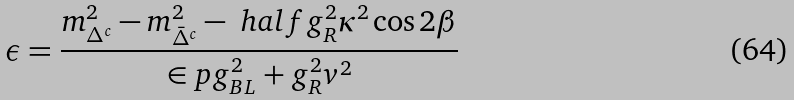Convert formula to latex. <formula><loc_0><loc_0><loc_500><loc_500>\epsilon = \frac { m _ { \Delta ^ { c } } ^ { 2 } - m _ { \bar { \Delta } ^ { c } } ^ { 2 } - \ h a l f g _ { R } ^ { 2 } \kappa ^ { 2 } \cos 2 \beta } { \in p { g _ { B L } ^ { 2 } + g _ { R } ^ { 2 } } v ^ { 2 } }</formula> 